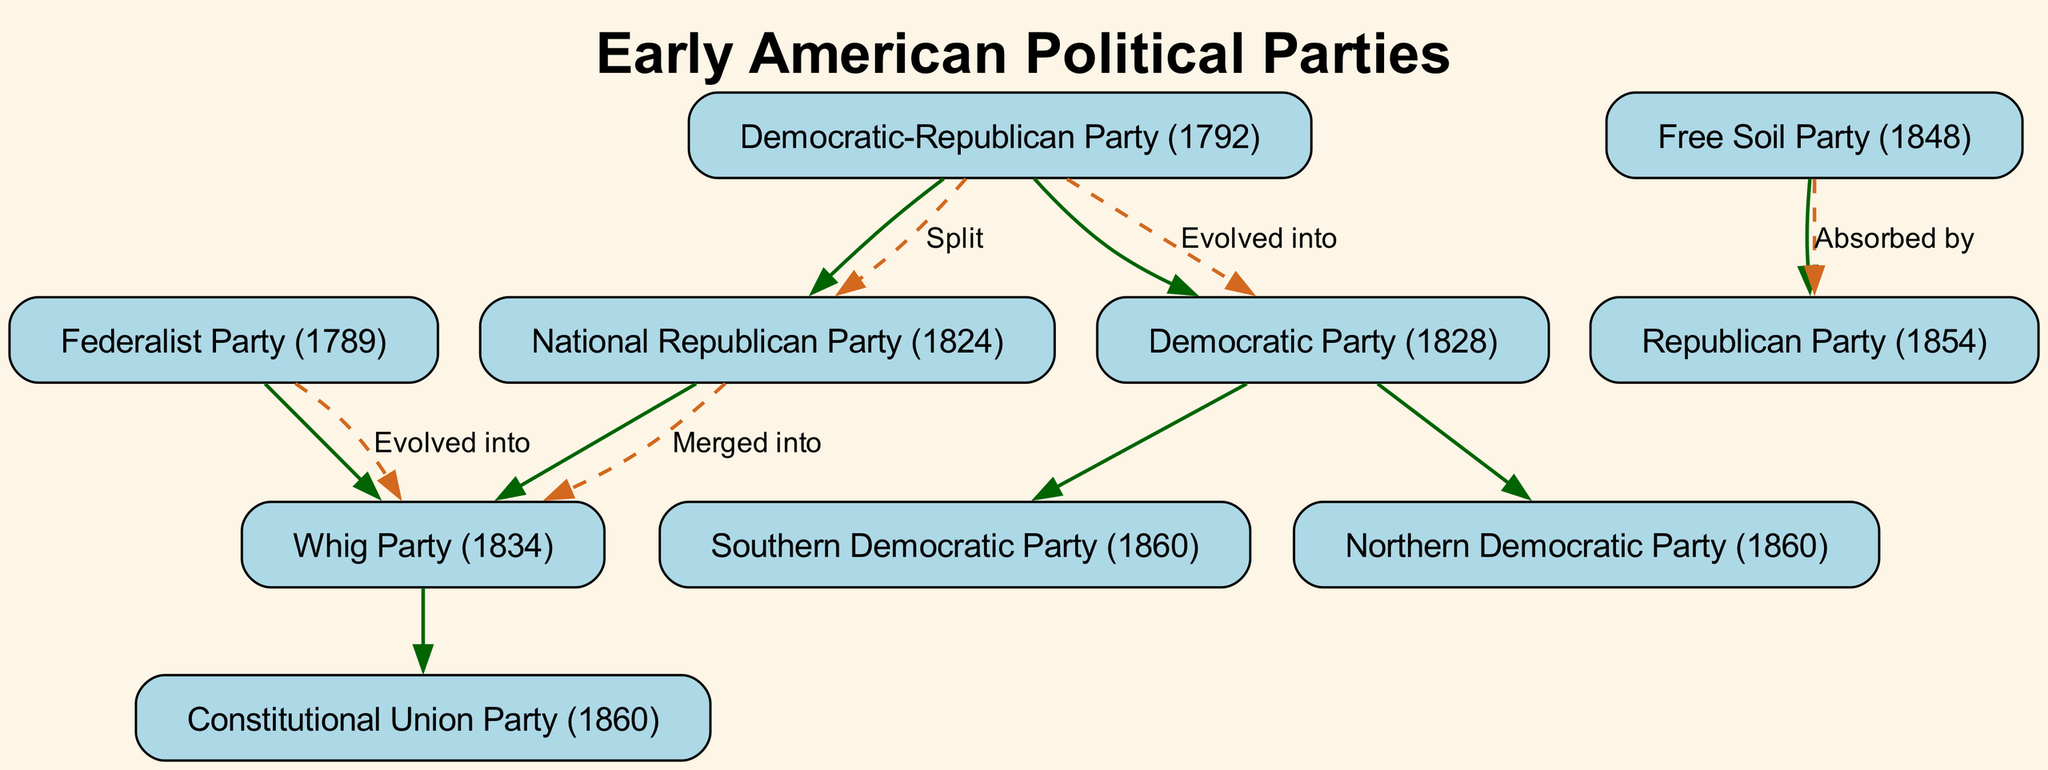What is the root of the diagram? The diagram represents the family tree of early American political parties, with the root being "Early American Political Parties."
Answer: Early American Political Parties How many nodes are in the diagram? By counting all the distinct political parties represented including the root, there are 9 nodes in total.
Answer: 9 What party evolved from the Federalist Party? According to the diagram, the Federalist Party evolved into the Whig Party.
Answer: Whig Party (1834) Which party was absorbed by the Republican Party? The diagram indicates that the Free Soil Party was absorbed by the Republican Party.
Answer: Free Soil Party (1848) What do the dashed lines between the nodes represent? The dashed lines indicate the nature of the relationships, such as splits, mergers, and evolution among the political parties in the diagram.
Answer: Relationships Which party split from the Democratic-Republican Party in 1824? The diagram shows that the National Republican Party split from the Democratic-Republican Party in 1824.
Answer: National Republican Party (1824) What year did the Whig Party emerge? The Whig Party emerged in the year 1834 as indicated in the diagram.
Answer: 1834 How many parties are children of the Democratic Party? There are two branches emerging from the Democratic Party, namely the Southern Democratic Party and the Northern Democratic Party.
Answer: 2 What was the parent party of the Republican Party? The diagram shows that the Republican Party evolved from the Free Soil Party, making the Free Soil Party its parent.
Answer: Free Soil Party (1848) 